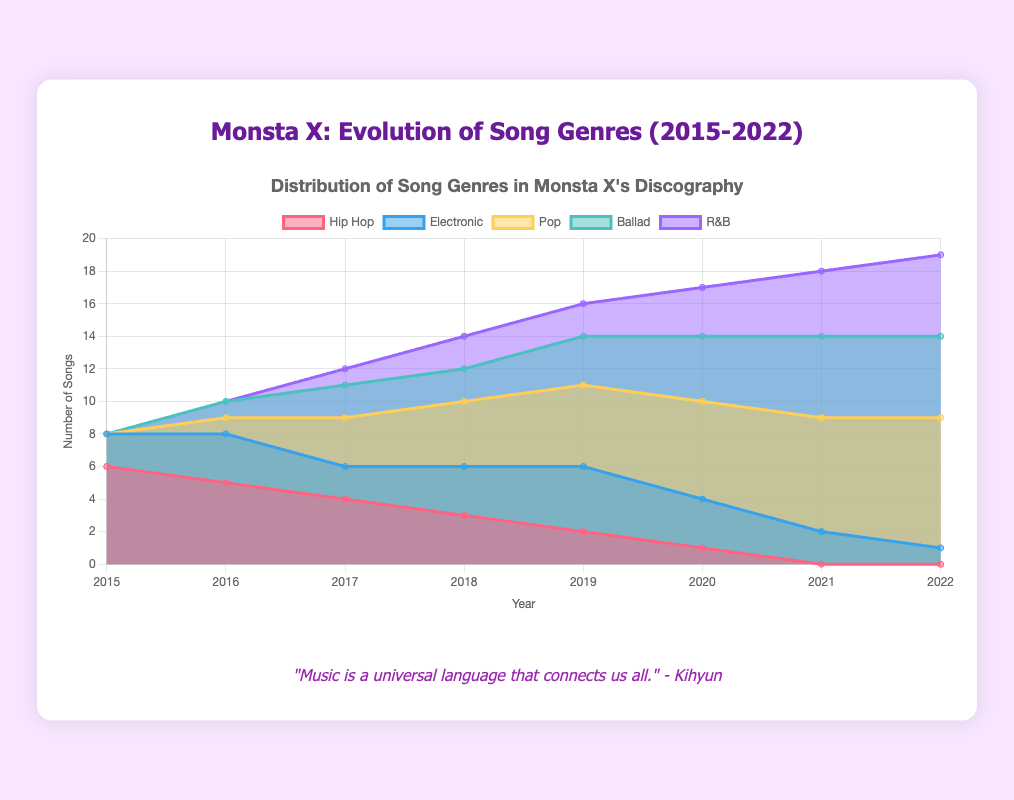what is the title of the chart? The title of the chart is displayed at the top and provides a summary of what the chart represents.
Answer: Monsta X: Evolution of Song Genres (2015-2022) How many years does the chart cover? Count the labels on the x-axis that represent the years. The years range from 2015 to 2022.
Answer: 8 years Which genre has the highest value in 2022? Look at the data points above the year 2022, and identify which color or area reaches the highest point.
Answer: Pop How many Pop songs are there in 2020? Identify the color representing Pop and look at the data point in 2020.
Answer: 6 Compare the number of Hip Hop and Ballad songs in 2017. Which is greater? Compare the data points for Hip Hop and Ballad above the year 2017.
Answer: Hip Hop Which genre showed a consistently increasing trend from 2016 to 2022? Observe the trend lines for each genre from 2016 to 2022 and see which one consistently increases.
Answer: Pop What is the total number of songs released in 2021? Sum all the genre values for the year 2021. (Hip Hop: 0, Electronic: 2, Pop: 7, Ballad: 5, R&B: 4) 0+2+7+5+4=18
Answer: 18 What year did the number of Hip Hop songs drop to zero? Check the Hip Hop data line for the first year it reads zero.
Answer: 2021 How does the number of Electronic songs change from 2015 to 2022? Look at the data points for Electronic each year and describe the trend from start to end.
Answer: It decreases overall Which year had the most diverse genre distribution (most spread across different genres)? Evaluate the years by comparing the distribution values for each genre and find the year with the highest variety.
Answer: 2018 How many genres are tracked in this chart? Count the number of distinct colors or dataset labels representing different genres in the chart.
Answer: 5 